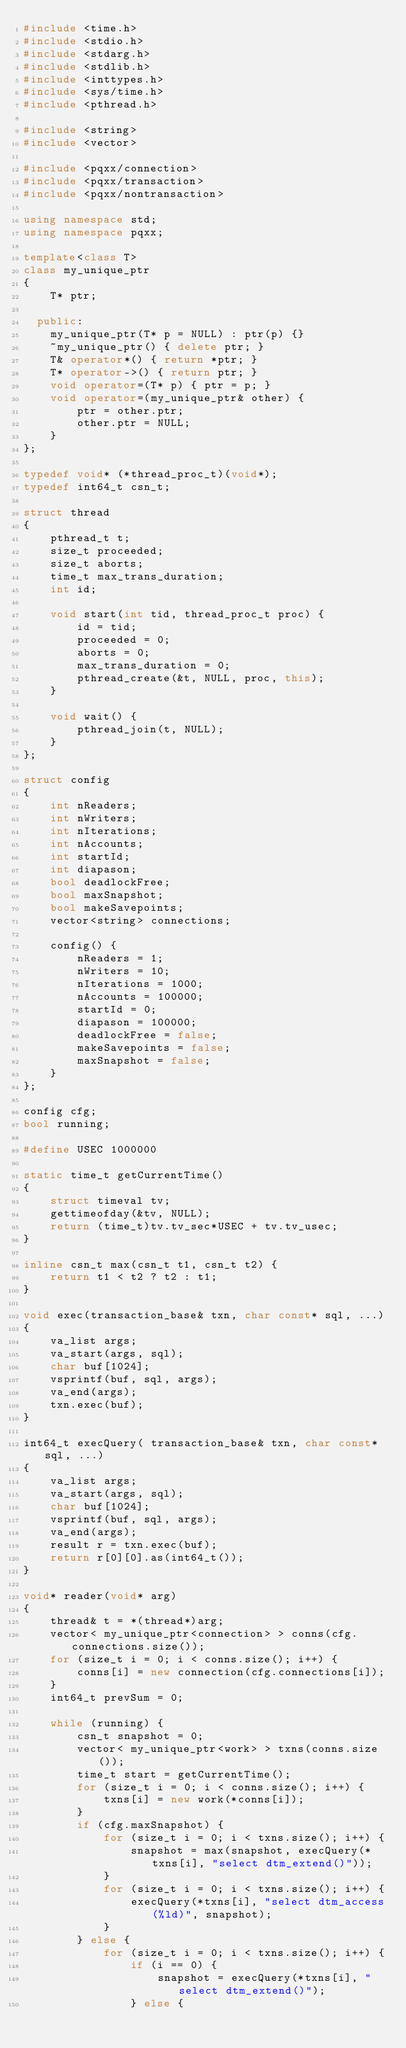<code> <loc_0><loc_0><loc_500><loc_500><_C++_>#include <time.h>
#include <stdio.h>
#include <stdarg.h>
#include <stdlib.h>
#include <inttypes.h>
#include <sys/time.h>
#include <pthread.h>

#include <string>
#include <vector>

#include <pqxx/connection>
#include <pqxx/transaction>
#include <pqxx/nontransaction>

using namespace std;
using namespace pqxx;

template<class T>
class my_unique_ptr
{
    T* ptr;
    
  public:
    my_unique_ptr(T* p = NULL) : ptr(p) {}
    ~my_unique_ptr() { delete ptr; }
    T& operator*() { return *ptr; }
    T* operator->() { return ptr; }
    void operator=(T* p) { ptr = p; }
    void operator=(my_unique_ptr& other) {
        ptr = other.ptr;
        other.ptr = NULL;
    }        
};

typedef void* (*thread_proc_t)(void*);
typedef int64_t csn_t;

struct thread
{
    pthread_t t;
    size_t proceeded;
    size_t aborts;
    time_t max_trans_duration;
    int id;

    void start(int tid, thread_proc_t proc) { 
        id = tid;
        proceeded = 0;
        aborts = 0;
        max_trans_duration = 0;
        pthread_create(&t, NULL, proc, this);
    }

    void wait() { 
        pthread_join(t, NULL);
    }
};

struct config
{
    int nReaders;
    int nWriters;
    int nIterations;
    int nAccounts;
    int startId;
    int diapason;
    bool deadlockFree;
    bool maxSnapshot;
    bool makeSavepoints;
    vector<string> connections;

    config() {
        nReaders = 1;
        nWriters = 10;
        nIterations = 1000;
        nAccounts = 100000;  
        startId = 0;
        diapason = 100000;
        deadlockFree = false;
        makeSavepoints = false;
        maxSnapshot = false;
    }
};

config cfg;
bool running;

#define USEC 1000000

static time_t getCurrentTime()
{
    struct timeval tv;
    gettimeofday(&tv, NULL);
    return (time_t)tv.tv_sec*USEC + tv.tv_usec;
}

inline csn_t max(csn_t t1, csn_t t2) { 
    return t1 < t2 ? t2 : t1;
}

void exec(transaction_base& txn, char const* sql, ...)
{
    va_list args;
    va_start(args, sql);
    char buf[1024];
    vsprintf(buf, sql, args);
    va_end(args);
    txn.exec(buf);
}

int64_t execQuery( transaction_base& txn, char const* sql, ...)
{
    va_list args;
    va_start(args, sql);
    char buf[1024];
    vsprintf(buf, sql, args);
    va_end(args);
    result r = txn.exec(buf);
    return r[0][0].as(int64_t());
}  

void* reader(void* arg)
{
    thread& t = *(thread*)arg;
    vector< my_unique_ptr<connection> > conns(cfg.connections.size());
    for (size_t i = 0; i < conns.size(); i++) {
        conns[i] = new connection(cfg.connections[i]);
    }
    int64_t prevSum = 0;

    while (running) {
        csn_t snapshot = 0;
        vector< my_unique_ptr<work> > txns(conns.size());
        time_t start = getCurrentTime();
        for (size_t i = 0; i < conns.size(); i++) {        
            txns[i] = new work(*conns[i]);
        }
        if (cfg.maxSnapshot) { 
            for (size_t i = 0; i < txns.size(); i++) {        
                snapshot = max(snapshot, execQuery(*txns[i], "select dtm_extend()"));
            }
            for (size_t i = 0; i < txns.size(); i++) {                    
                execQuery(*txns[i], "select dtm_access(%ld)", snapshot);
            }
        } else {             
            for (size_t i = 0; i < txns.size(); i++) {        
                if (i == 0) {
                    snapshot = execQuery(*txns[i], "select dtm_extend()");
                } else {</code> 